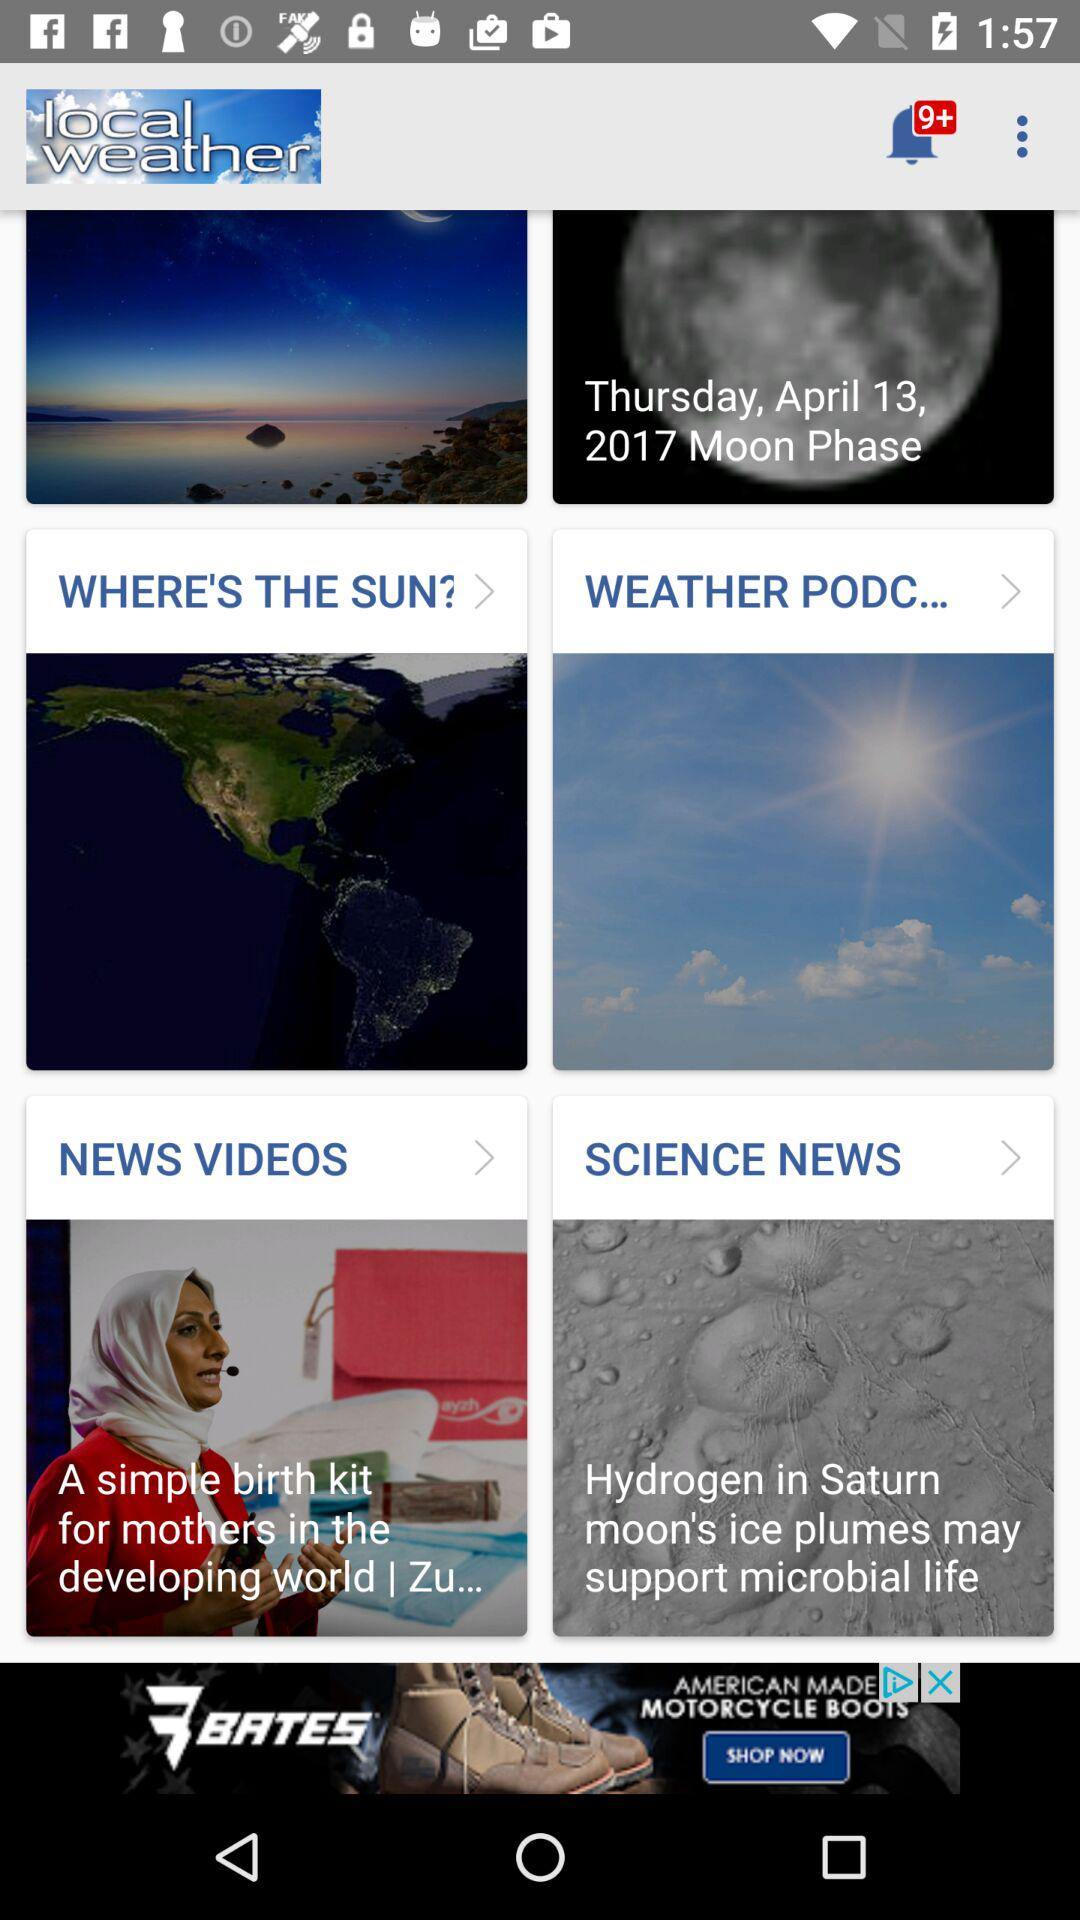How many notifications are pending? There are more than 9 pending notifications. 